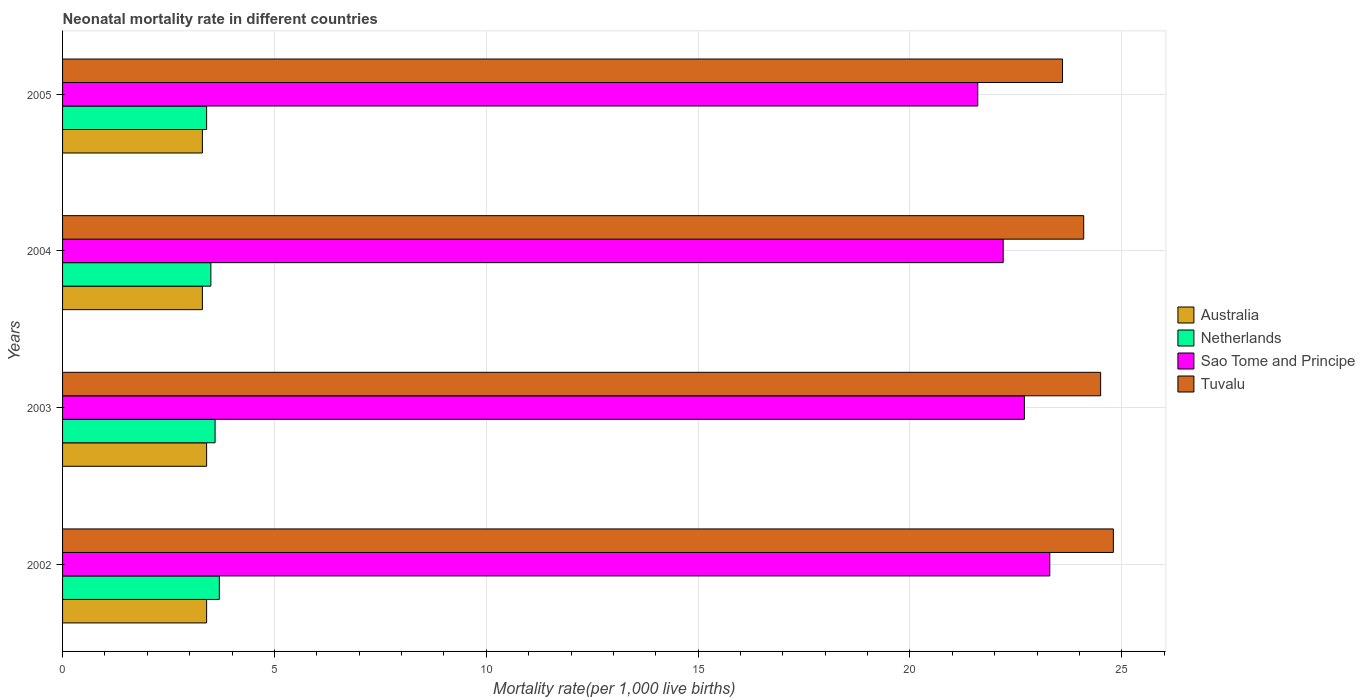How many different coloured bars are there?
Give a very brief answer. 4. Are the number of bars per tick equal to the number of legend labels?
Your response must be concise. Yes. Are the number of bars on each tick of the Y-axis equal?
Offer a terse response. Yes. What is the neonatal mortality rate in Sao Tome and Principe in 2002?
Provide a succinct answer. 23.3. Across all years, what is the minimum neonatal mortality rate in Sao Tome and Principe?
Your answer should be compact. 21.6. What is the total neonatal mortality rate in Sao Tome and Principe in the graph?
Give a very brief answer. 89.8. What is the difference between the neonatal mortality rate in Tuvalu in 2002 and that in 2005?
Offer a terse response. 1.2. What is the difference between the neonatal mortality rate in Australia in 2003 and the neonatal mortality rate in Sao Tome and Principe in 2002?
Keep it short and to the point. -19.9. What is the average neonatal mortality rate in Australia per year?
Ensure brevity in your answer.  3.35. In the year 2002, what is the difference between the neonatal mortality rate in Netherlands and neonatal mortality rate in Tuvalu?
Provide a short and direct response. -21.1. What is the ratio of the neonatal mortality rate in Tuvalu in 2002 to that in 2005?
Make the answer very short. 1.05. Is the neonatal mortality rate in Australia in 2004 less than that in 2005?
Provide a succinct answer. No. What is the difference between the highest and the lowest neonatal mortality rate in Tuvalu?
Your answer should be very brief. 1.2. Is the sum of the neonatal mortality rate in Sao Tome and Principe in 2002 and 2003 greater than the maximum neonatal mortality rate in Tuvalu across all years?
Ensure brevity in your answer.  Yes. Is it the case that in every year, the sum of the neonatal mortality rate in Sao Tome and Principe and neonatal mortality rate in Netherlands is greater than the sum of neonatal mortality rate in Tuvalu and neonatal mortality rate in Australia?
Your answer should be very brief. No. What does the 2nd bar from the bottom in 2004 represents?
Offer a very short reply. Netherlands. How many bars are there?
Keep it short and to the point. 16. Are all the bars in the graph horizontal?
Your answer should be very brief. Yes. What is the difference between two consecutive major ticks on the X-axis?
Make the answer very short. 5. Are the values on the major ticks of X-axis written in scientific E-notation?
Your answer should be very brief. No. How are the legend labels stacked?
Keep it short and to the point. Vertical. What is the title of the graph?
Provide a succinct answer. Neonatal mortality rate in different countries. Does "Lebanon" appear as one of the legend labels in the graph?
Provide a succinct answer. No. What is the label or title of the X-axis?
Offer a very short reply. Mortality rate(per 1,0 live births). What is the label or title of the Y-axis?
Give a very brief answer. Years. What is the Mortality rate(per 1,000 live births) in Sao Tome and Principe in 2002?
Offer a very short reply. 23.3. What is the Mortality rate(per 1,000 live births) in Tuvalu in 2002?
Make the answer very short. 24.8. What is the Mortality rate(per 1,000 live births) in Australia in 2003?
Provide a short and direct response. 3.4. What is the Mortality rate(per 1,000 live births) of Sao Tome and Principe in 2003?
Offer a terse response. 22.7. What is the Mortality rate(per 1,000 live births) in Tuvalu in 2003?
Make the answer very short. 24.5. What is the Mortality rate(per 1,000 live births) of Australia in 2004?
Offer a very short reply. 3.3. What is the Mortality rate(per 1,000 live births) of Tuvalu in 2004?
Your answer should be compact. 24.1. What is the Mortality rate(per 1,000 live births) of Netherlands in 2005?
Ensure brevity in your answer.  3.4. What is the Mortality rate(per 1,000 live births) in Sao Tome and Principe in 2005?
Ensure brevity in your answer.  21.6. What is the Mortality rate(per 1,000 live births) in Tuvalu in 2005?
Keep it short and to the point. 23.6. Across all years, what is the maximum Mortality rate(per 1,000 live births) of Australia?
Give a very brief answer. 3.4. Across all years, what is the maximum Mortality rate(per 1,000 live births) of Netherlands?
Provide a succinct answer. 3.7. Across all years, what is the maximum Mortality rate(per 1,000 live births) of Sao Tome and Principe?
Offer a very short reply. 23.3. Across all years, what is the maximum Mortality rate(per 1,000 live births) in Tuvalu?
Offer a very short reply. 24.8. Across all years, what is the minimum Mortality rate(per 1,000 live births) of Sao Tome and Principe?
Your answer should be very brief. 21.6. Across all years, what is the minimum Mortality rate(per 1,000 live births) of Tuvalu?
Offer a very short reply. 23.6. What is the total Mortality rate(per 1,000 live births) in Australia in the graph?
Keep it short and to the point. 13.4. What is the total Mortality rate(per 1,000 live births) of Netherlands in the graph?
Give a very brief answer. 14.2. What is the total Mortality rate(per 1,000 live births) in Sao Tome and Principe in the graph?
Keep it short and to the point. 89.8. What is the total Mortality rate(per 1,000 live births) of Tuvalu in the graph?
Make the answer very short. 97. What is the difference between the Mortality rate(per 1,000 live births) of Australia in 2002 and that in 2003?
Keep it short and to the point. 0. What is the difference between the Mortality rate(per 1,000 live births) of Netherlands in 2002 and that in 2003?
Offer a terse response. 0.1. What is the difference between the Mortality rate(per 1,000 live births) in Sao Tome and Principe in 2002 and that in 2003?
Your response must be concise. 0.6. What is the difference between the Mortality rate(per 1,000 live births) in Netherlands in 2002 and that in 2004?
Ensure brevity in your answer.  0.2. What is the difference between the Mortality rate(per 1,000 live births) in Sao Tome and Principe in 2002 and that in 2004?
Your answer should be compact. 1.1. What is the difference between the Mortality rate(per 1,000 live births) of Australia in 2002 and that in 2005?
Provide a succinct answer. 0.1. What is the difference between the Mortality rate(per 1,000 live births) of Sao Tome and Principe in 2002 and that in 2005?
Make the answer very short. 1.7. What is the difference between the Mortality rate(per 1,000 live births) in Tuvalu in 2002 and that in 2005?
Ensure brevity in your answer.  1.2. What is the difference between the Mortality rate(per 1,000 live births) in Sao Tome and Principe in 2003 and that in 2004?
Give a very brief answer. 0.5. What is the difference between the Mortality rate(per 1,000 live births) of Sao Tome and Principe in 2003 and that in 2005?
Make the answer very short. 1.1. What is the difference between the Mortality rate(per 1,000 live births) in Tuvalu in 2003 and that in 2005?
Provide a short and direct response. 0.9. What is the difference between the Mortality rate(per 1,000 live births) in Netherlands in 2004 and that in 2005?
Provide a succinct answer. 0.1. What is the difference between the Mortality rate(per 1,000 live births) of Sao Tome and Principe in 2004 and that in 2005?
Your answer should be very brief. 0.6. What is the difference between the Mortality rate(per 1,000 live births) of Tuvalu in 2004 and that in 2005?
Your answer should be very brief. 0.5. What is the difference between the Mortality rate(per 1,000 live births) of Australia in 2002 and the Mortality rate(per 1,000 live births) of Netherlands in 2003?
Provide a succinct answer. -0.2. What is the difference between the Mortality rate(per 1,000 live births) of Australia in 2002 and the Mortality rate(per 1,000 live births) of Sao Tome and Principe in 2003?
Offer a very short reply. -19.3. What is the difference between the Mortality rate(per 1,000 live births) in Australia in 2002 and the Mortality rate(per 1,000 live births) in Tuvalu in 2003?
Provide a short and direct response. -21.1. What is the difference between the Mortality rate(per 1,000 live births) in Netherlands in 2002 and the Mortality rate(per 1,000 live births) in Sao Tome and Principe in 2003?
Your response must be concise. -19. What is the difference between the Mortality rate(per 1,000 live births) of Netherlands in 2002 and the Mortality rate(per 1,000 live births) of Tuvalu in 2003?
Your response must be concise. -20.8. What is the difference between the Mortality rate(per 1,000 live births) of Sao Tome and Principe in 2002 and the Mortality rate(per 1,000 live births) of Tuvalu in 2003?
Offer a terse response. -1.2. What is the difference between the Mortality rate(per 1,000 live births) of Australia in 2002 and the Mortality rate(per 1,000 live births) of Netherlands in 2004?
Offer a very short reply. -0.1. What is the difference between the Mortality rate(per 1,000 live births) in Australia in 2002 and the Mortality rate(per 1,000 live births) in Sao Tome and Principe in 2004?
Ensure brevity in your answer.  -18.8. What is the difference between the Mortality rate(per 1,000 live births) of Australia in 2002 and the Mortality rate(per 1,000 live births) of Tuvalu in 2004?
Make the answer very short. -20.7. What is the difference between the Mortality rate(per 1,000 live births) of Netherlands in 2002 and the Mortality rate(per 1,000 live births) of Sao Tome and Principe in 2004?
Offer a terse response. -18.5. What is the difference between the Mortality rate(per 1,000 live births) in Netherlands in 2002 and the Mortality rate(per 1,000 live births) in Tuvalu in 2004?
Offer a terse response. -20.4. What is the difference between the Mortality rate(per 1,000 live births) of Australia in 2002 and the Mortality rate(per 1,000 live births) of Sao Tome and Principe in 2005?
Keep it short and to the point. -18.2. What is the difference between the Mortality rate(per 1,000 live births) of Australia in 2002 and the Mortality rate(per 1,000 live births) of Tuvalu in 2005?
Offer a terse response. -20.2. What is the difference between the Mortality rate(per 1,000 live births) in Netherlands in 2002 and the Mortality rate(per 1,000 live births) in Sao Tome and Principe in 2005?
Give a very brief answer. -17.9. What is the difference between the Mortality rate(per 1,000 live births) of Netherlands in 2002 and the Mortality rate(per 1,000 live births) of Tuvalu in 2005?
Provide a succinct answer. -19.9. What is the difference between the Mortality rate(per 1,000 live births) of Sao Tome and Principe in 2002 and the Mortality rate(per 1,000 live births) of Tuvalu in 2005?
Ensure brevity in your answer.  -0.3. What is the difference between the Mortality rate(per 1,000 live births) of Australia in 2003 and the Mortality rate(per 1,000 live births) of Sao Tome and Principe in 2004?
Your response must be concise. -18.8. What is the difference between the Mortality rate(per 1,000 live births) of Australia in 2003 and the Mortality rate(per 1,000 live births) of Tuvalu in 2004?
Your response must be concise. -20.7. What is the difference between the Mortality rate(per 1,000 live births) in Netherlands in 2003 and the Mortality rate(per 1,000 live births) in Sao Tome and Principe in 2004?
Make the answer very short. -18.6. What is the difference between the Mortality rate(per 1,000 live births) in Netherlands in 2003 and the Mortality rate(per 1,000 live births) in Tuvalu in 2004?
Ensure brevity in your answer.  -20.5. What is the difference between the Mortality rate(per 1,000 live births) in Australia in 2003 and the Mortality rate(per 1,000 live births) in Netherlands in 2005?
Ensure brevity in your answer.  0. What is the difference between the Mortality rate(per 1,000 live births) in Australia in 2003 and the Mortality rate(per 1,000 live births) in Sao Tome and Principe in 2005?
Make the answer very short. -18.2. What is the difference between the Mortality rate(per 1,000 live births) in Australia in 2003 and the Mortality rate(per 1,000 live births) in Tuvalu in 2005?
Keep it short and to the point. -20.2. What is the difference between the Mortality rate(per 1,000 live births) in Netherlands in 2003 and the Mortality rate(per 1,000 live births) in Tuvalu in 2005?
Keep it short and to the point. -20. What is the difference between the Mortality rate(per 1,000 live births) in Australia in 2004 and the Mortality rate(per 1,000 live births) in Sao Tome and Principe in 2005?
Provide a succinct answer. -18.3. What is the difference between the Mortality rate(per 1,000 live births) in Australia in 2004 and the Mortality rate(per 1,000 live births) in Tuvalu in 2005?
Make the answer very short. -20.3. What is the difference between the Mortality rate(per 1,000 live births) in Netherlands in 2004 and the Mortality rate(per 1,000 live births) in Sao Tome and Principe in 2005?
Offer a very short reply. -18.1. What is the difference between the Mortality rate(per 1,000 live births) in Netherlands in 2004 and the Mortality rate(per 1,000 live births) in Tuvalu in 2005?
Make the answer very short. -20.1. What is the average Mortality rate(per 1,000 live births) of Australia per year?
Your response must be concise. 3.35. What is the average Mortality rate(per 1,000 live births) in Netherlands per year?
Offer a terse response. 3.55. What is the average Mortality rate(per 1,000 live births) of Sao Tome and Principe per year?
Provide a short and direct response. 22.45. What is the average Mortality rate(per 1,000 live births) in Tuvalu per year?
Your answer should be compact. 24.25. In the year 2002, what is the difference between the Mortality rate(per 1,000 live births) of Australia and Mortality rate(per 1,000 live births) of Netherlands?
Offer a terse response. -0.3. In the year 2002, what is the difference between the Mortality rate(per 1,000 live births) of Australia and Mortality rate(per 1,000 live births) of Sao Tome and Principe?
Give a very brief answer. -19.9. In the year 2002, what is the difference between the Mortality rate(per 1,000 live births) in Australia and Mortality rate(per 1,000 live births) in Tuvalu?
Make the answer very short. -21.4. In the year 2002, what is the difference between the Mortality rate(per 1,000 live births) in Netherlands and Mortality rate(per 1,000 live births) in Sao Tome and Principe?
Ensure brevity in your answer.  -19.6. In the year 2002, what is the difference between the Mortality rate(per 1,000 live births) in Netherlands and Mortality rate(per 1,000 live births) in Tuvalu?
Ensure brevity in your answer.  -21.1. In the year 2002, what is the difference between the Mortality rate(per 1,000 live births) of Sao Tome and Principe and Mortality rate(per 1,000 live births) of Tuvalu?
Offer a very short reply. -1.5. In the year 2003, what is the difference between the Mortality rate(per 1,000 live births) in Australia and Mortality rate(per 1,000 live births) in Netherlands?
Offer a very short reply. -0.2. In the year 2003, what is the difference between the Mortality rate(per 1,000 live births) in Australia and Mortality rate(per 1,000 live births) in Sao Tome and Principe?
Provide a short and direct response. -19.3. In the year 2003, what is the difference between the Mortality rate(per 1,000 live births) in Australia and Mortality rate(per 1,000 live births) in Tuvalu?
Your answer should be very brief. -21.1. In the year 2003, what is the difference between the Mortality rate(per 1,000 live births) of Netherlands and Mortality rate(per 1,000 live births) of Sao Tome and Principe?
Your answer should be compact. -19.1. In the year 2003, what is the difference between the Mortality rate(per 1,000 live births) of Netherlands and Mortality rate(per 1,000 live births) of Tuvalu?
Offer a terse response. -20.9. In the year 2003, what is the difference between the Mortality rate(per 1,000 live births) of Sao Tome and Principe and Mortality rate(per 1,000 live births) of Tuvalu?
Make the answer very short. -1.8. In the year 2004, what is the difference between the Mortality rate(per 1,000 live births) of Australia and Mortality rate(per 1,000 live births) of Netherlands?
Your answer should be very brief. -0.2. In the year 2004, what is the difference between the Mortality rate(per 1,000 live births) of Australia and Mortality rate(per 1,000 live births) of Sao Tome and Principe?
Keep it short and to the point. -18.9. In the year 2004, what is the difference between the Mortality rate(per 1,000 live births) of Australia and Mortality rate(per 1,000 live births) of Tuvalu?
Your answer should be very brief. -20.8. In the year 2004, what is the difference between the Mortality rate(per 1,000 live births) in Netherlands and Mortality rate(per 1,000 live births) in Sao Tome and Principe?
Ensure brevity in your answer.  -18.7. In the year 2004, what is the difference between the Mortality rate(per 1,000 live births) of Netherlands and Mortality rate(per 1,000 live births) of Tuvalu?
Offer a very short reply. -20.6. In the year 2005, what is the difference between the Mortality rate(per 1,000 live births) in Australia and Mortality rate(per 1,000 live births) in Sao Tome and Principe?
Your answer should be very brief. -18.3. In the year 2005, what is the difference between the Mortality rate(per 1,000 live births) in Australia and Mortality rate(per 1,000 live births) in Tuvalu?
Your response must be concise. -20.3. In the year 2005, what is the difference between the Mortality rate(per 1,000 live births) of Netherlands and Mortality rate(per 1,000 live births) of Sao Tome and Principe?
Your response must be concise. -18.2. In the year 2005, what is the difference between the Mortality rate(per 1,000 live births) of Netherlands and Mortality rate(per 1,000 live births) of Tuvalu?
Your response must be concise. -20.2. In the year 2005, what is the difference between the Mortality rate(per 1,000 live births) in Sao Tome and Principe and Mortality rate(per 1,000 live births) in Tuvalu?
Provide a short and direct response. -2. What is the ratio of the Mortality rate(per 1,000 live births) in Netherlands in 2002 to that in 2003?
Make the answer very short. 1.03. What is the ratio of the Mortality rate(per 1,000 live births) of Sao Tome and Principe in 2002 to that in 2003?
Provide a short and direct response. 1.03. What is the ratio of the Mortality rate(per 1,000 live births) in Tuvalu in 2002 to that in 2003?
Your answer should be very brief. 1.01. What is the ratio of the Mortality rate(per 1,000 live births) in Australia in 2002 to that in 2004?
Provide a short and direct response. 1.03. What is the ratio of the Mortality rate(per 1,000 live births) of Netherlands in 2002 to that in 2004?
Provide a succinct answer. 1.06. What is the ratio of the Mortality rate(per 1,000 live births) in Sao Tome and Principe in 2002 to that in 2004?
Provide a short and direct response. 1.05. What is the ratio of the Mortality rate(per 1,000 live births) of Australia in 2002 to that in 2005?
Your answer should be compact. 1.03. What is the ratio of the Mortality rate(per 1,000 live births) of Netherlands in 2002 to that in 2005?
Offer a terse response. 1.09. What is the ratio of the Mortality rate(per 1,000 live births) of Sao Tome and Principe in 2002 to that in 2005?
Keep it short and to the point. 1.08. What is the ratio of the Mortality rate(per 1,000 live births) in Tuvalu in 2002 to that in 2005?
Your answer should be compact. 1.05. What is the ratio of the Mortality rate(per 1,000 live births) in Australia in 2003 to that in 2004?
Keep it short and to the point. 1.03. What is the ratio of the Mortality rate(per 1,000 live births) of Netherlands in 2003 to that in 2004?
Provide a succinct answer. 1.03. What is the ratio of the Mortality rate(per 1,000 live births) in Sao Tome and Principe in 2003 to that in 2004?
Your response must be concise. 1.02. What is the ratio of the Mortality rate(per 1,000 live births) in Tuvalu in 2003 to that in 2004?
Your answer should be very brief. 1.02. What is the ratio of the Mortality rate(per 1,000 live births) in Australia in 2003 to that in 2005?
Ensure brevity in your answer.  1.03. What is the ratio of the Mortality rate(per 1,000 live births) in Netherlands in 2003 to that in 2005?
Your response must be concise. 1.06. What is the ratio of the Mortality rate(per 1,000 live births) of Sao Tome and Principe in 2003 to that in 2005?
Your response must be concise. 1.05. What is the ratio of the Mortality rate(per 1,000 live births) of Tuvalu in 2003 to that in 2005?
Provide a succinct answer. 1.04. What is the ratio of the Mortality rate(per 1,000 live births) of Australia in 2004 to that in 2005?
Provide a short and direct response. 1. What is the ratio of the Mortality rate(per 1,000 live births) of Netherlands in 2004 to that in 2005?
Make the answer very short. 1.03. What is the ratio of the Mortality rate(per 1,000 live births) of Sao Tome and Principe in 2004 to that in 2005?
Your answer should be very brief. 1.03. What is the ratio of the Mortality rate(per 1,000 live births) of Tuvalu in 2004 to that in 2005?
Keep it short and to the point. 1.02. What is the difference between the highest and the second highest Mortality rate(per 1,000 live births) of Netherlands?
Offer a very short reply. 0.1. What is the difference between the highest and the second highest Mortality rate(per 1,000 live births) in Tuvalu?
Your answer should be compact. 0.3. What is the difference between the highest and the lowest Mortality rate(per 1,000 live births) of Sao Tome and Principe?
Offer a terse response. 1.7. What is the difference between the highest and the lowest Mortality rate(per 1,000 live births) in Tuvalu?
Provide a succinct answer. 1.2. 